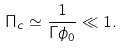Convert formula to latex. <formula><loc_0><loc_0><loc_500><loc_500>\Pi _ { c } \simeq \frac { 1 } { \Gamma \phi _ { 0 } } \ll 1 .</formula> 